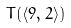Convert formula to latex. <formula><loc_0><loc_0><loc_500><loc_500>T ( \langle 9 , 2 \rangle )</formula> 